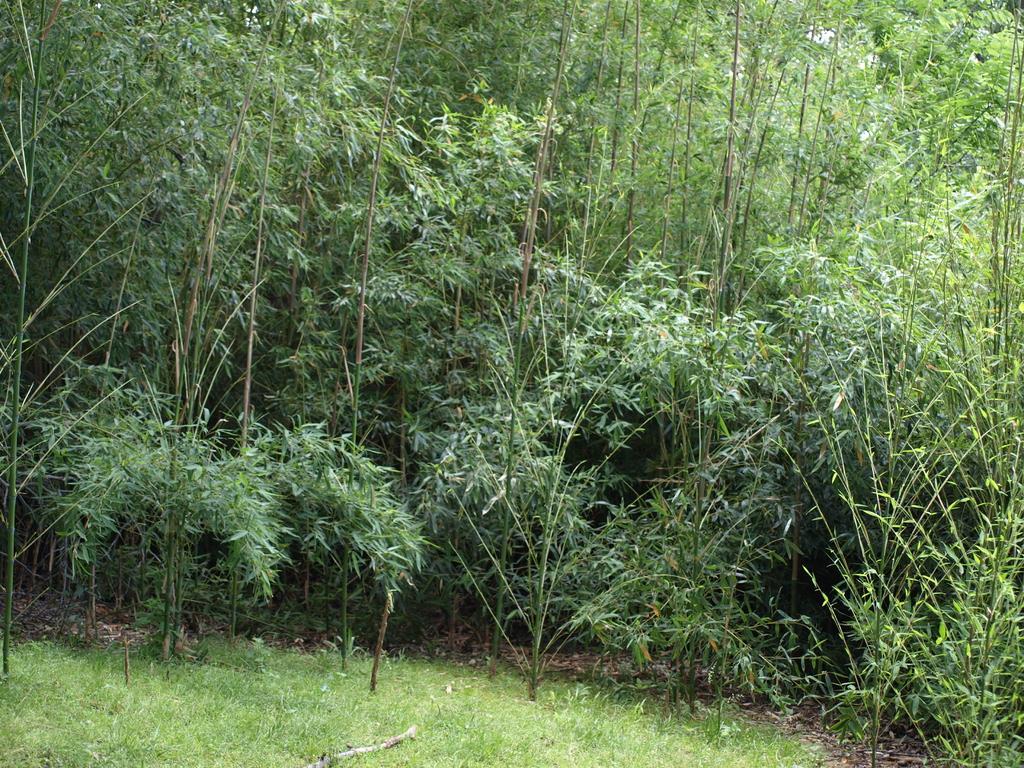Please provide a concise description of this image. At the bottom of the image there is grass on the ground. Also there are many trees. 